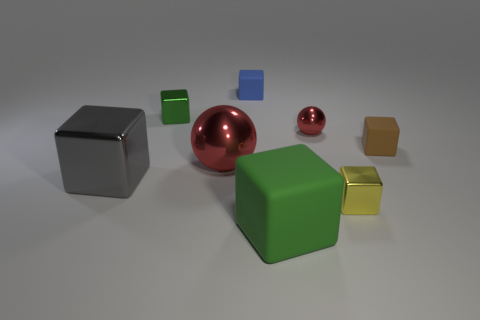Do the gray metallic object and the blue cube have the same size?
Make the answer very short. No. The yellow metallic cube is what size?
Keep it short and to the point. Small. What is the color of the large object that is to the right of the shiny ball that is in front of the matte cube right of the tiny yellow cube?
Give a very brief answer. Green. There is a large metal object that is behind the large metal block; is it the same shape as the green shiny thing?
Ensure brevity in your answer.  No. There is a ball that is the same size as the green rubber cube; what is its color?
Offer a terse response. Red. What number of tiny brown cylinders are there?
Make the answer very short. 0. Is the tiny thing in front of the large shiny block made of the same material as the tiny ball?
Ensure brevity in your answer.  Yes. There is a object that is to the right of the large green thing and in front of the gray shiny object; what material is it?
Ensure brevity in your answer.  Metal. The other metal sphere that is the same color as the small metal sphere is what size?
Offer a terse response. Large. There is a large cube on the right side of the green object that is behind the big matte cube; what is it made of?
Offer a very short reply. Rubber. 